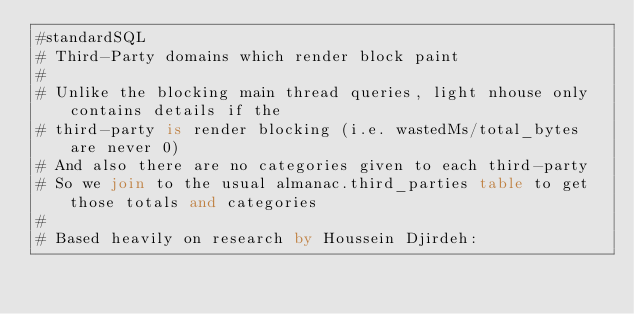<code> <loc_0><loc_0><loc_500><loc_500><_SQL_>#standardSQL
# Third-Party domains which render block paint
#
# Unlike the blocking main thread queries, light nhouse only contains details if the
# third-party is render blocking (i.e. wastedMs/total_bytes are never 0)
# And also there are no categories given to each third-party
# So we join to the usual almanac.third_parties table to get those totals and categories
#
# Based heavily on research by Houssein Djirdeh:</code> 